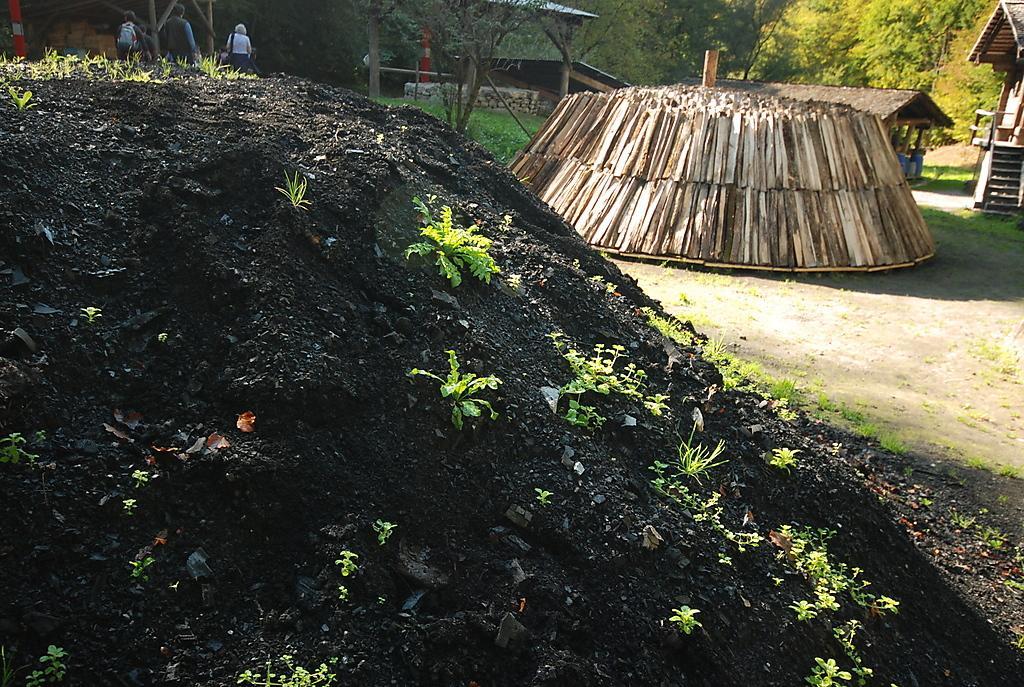Can you describe this image briefly? In this picture there are buildings and trees. On the left side of the image there are three persons and there are wood sticks in the foreground and there is black soil. At the bottom there is grass. 